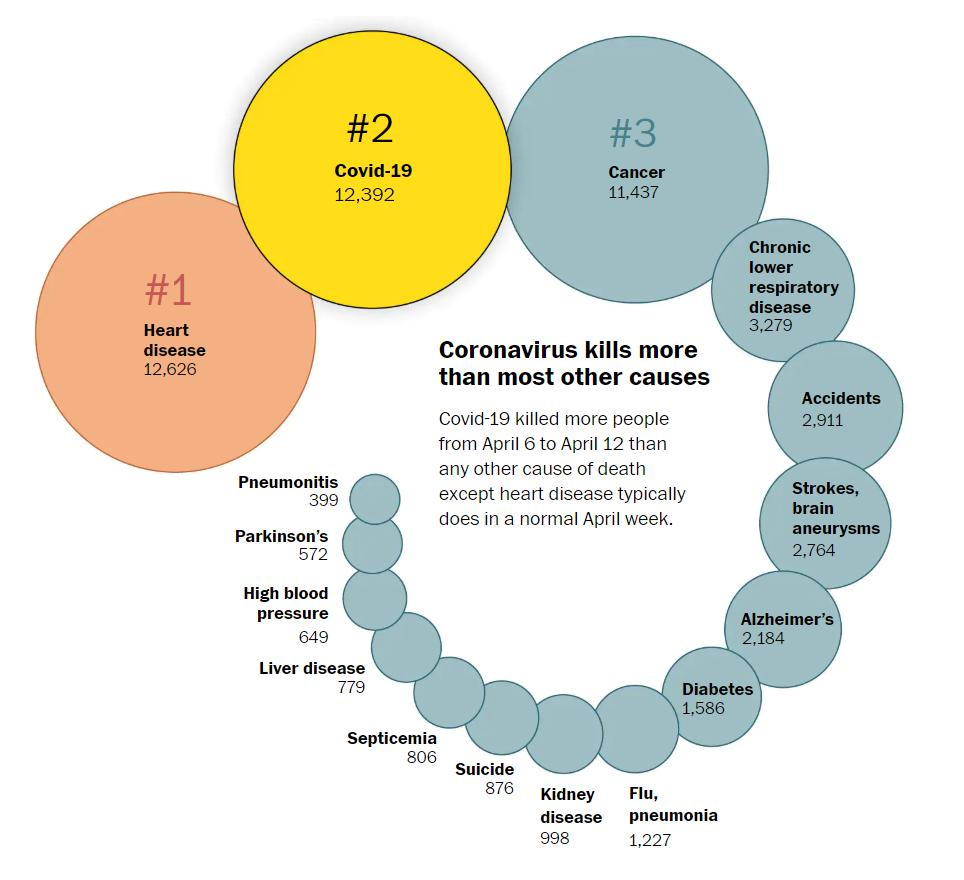Mention a couple of crucial points in this snapshot. During the period of April 6-12, a total of 876 people were killed by suicide. During the week of April 6-12, a total of 2,911 people were killed in accidents. During the week of April 6-12, heart disease was the cause of the most deaths among the population. During a typical April week, pneumonitis is the disease that has caused the least amount of deaths, according to recent data. This finding is significant as it highlights the potential of this disease to cause minimal harm to individuals and society as a whole. It is important to continue research and monitoring of pneumonitis to further understand its impact and potential for prevention and treatment. During April 6-12, a total of 779 people were killed by liver disease. 